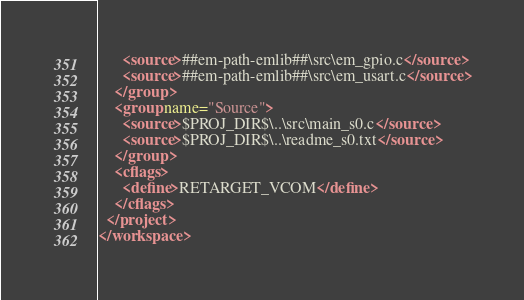<code> <loc_0><loc_0><loc_500><loc_500><_XML_>      <source>##em-path-emlib##\src\em_gpio.c</source>
      <source>##em-path-emlib##\src\em_usart.c</source>
    </group>
    <group name="Source">
      <source>$PROJ_DIR$\..\src\main_s0.c</source>
      <source>$PROJ_DIR$\..\readme_s0.txt</source>
    </group>
    <cflags>
      <define>RETARGET_VCOM</define>
    </cflags>
  </project>
</workspace>
</code> 